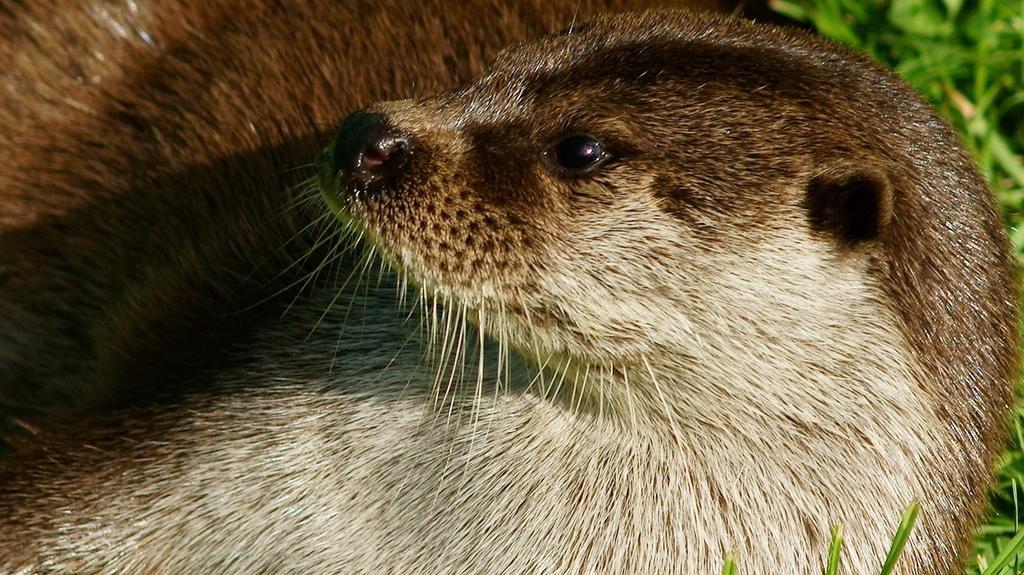How would you summarize this image in a sentence or two? In this image we can see an animal and in the background, we can see plants. 